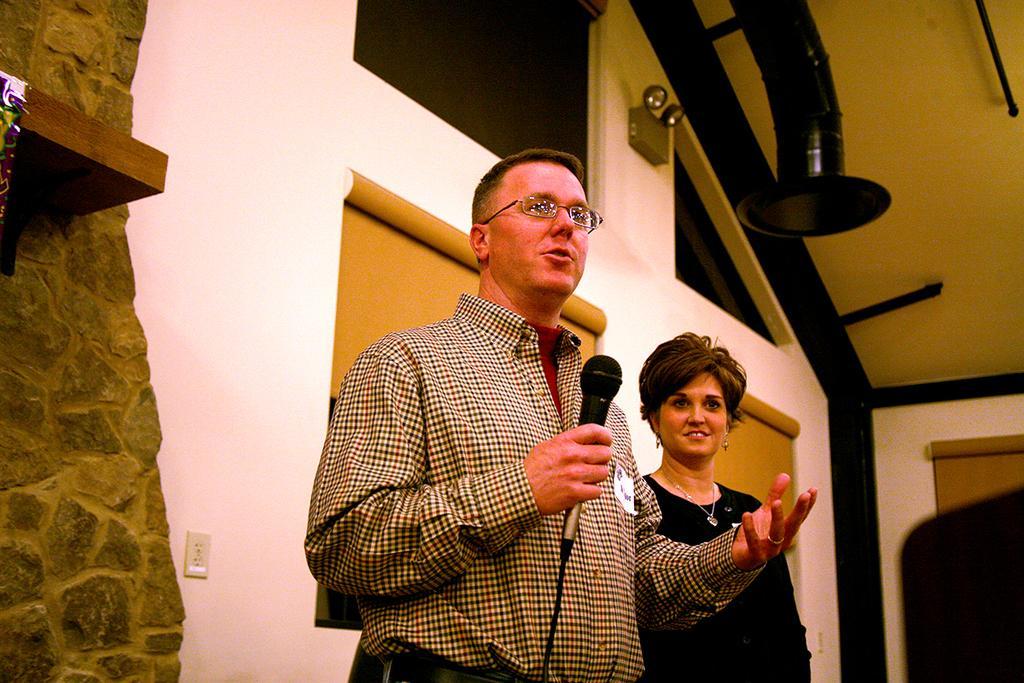Describe this image in one or two sentences. In the middle a man is standing and holding a microphone in his hands speaking in it. He wears spectacles and shirt beside of him a woman is standing and wearing a black color dress. She is smiling too behind them there is a wall. 